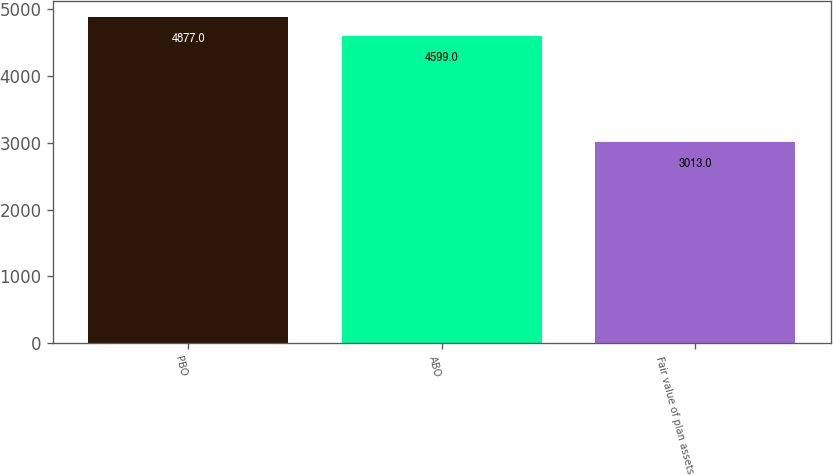<chart> <loc_0><loc_0><loc_500><loc_500><bar_chart><fcel>PBO<fcel>ABO<fcel>Fair value of plan assets<nl><fcel>4877<fcel>4599<fcel>3013<nl></chart> 